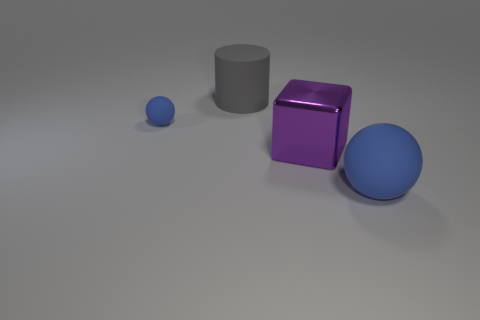What is the size of the other rubber object that is the same shape as the small object?
Make the answer very short. Large. What is the color of the large object that is both in front of the small blue rubber object and behind the big matte sphere?
Offer a very short reply. Purple. Are the tiny blue object and the blue ball in front of the small rubber sphere made of the same material?
Ensure brevity in your answer.  Yes. Is the number of large blue matte spheres that are right of the large rubber sphere less than the number of matte spheres?
Your answer should be very brief. Yes. What number of other objects are there of the same shape as the big blue thing?
Make the answer very short. 1. Is there anything else that is the same color as the small matte object?
Ensure brevity in your answer.  Yes. Do the big cube and the large matte thing behind the large matte sphere have the same color?
Ensure brevity in your answer.  No. What number of other objects are there of the same size as the metallic cube?
Your answer should be very brief. 2. What size is the other rubber sphere that is the same color as the tiny ball?
Give a very brief answer. Large. What number of spheres are small things or big purple things?
Offer a terse response. 1. 